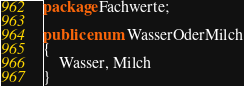<code> <loc_0><loc_0><loc_500><loc_500><_Java_>package Fachwerte;

public enum WasserOderMilch
{
    Wasser, Milch
}
</code> 